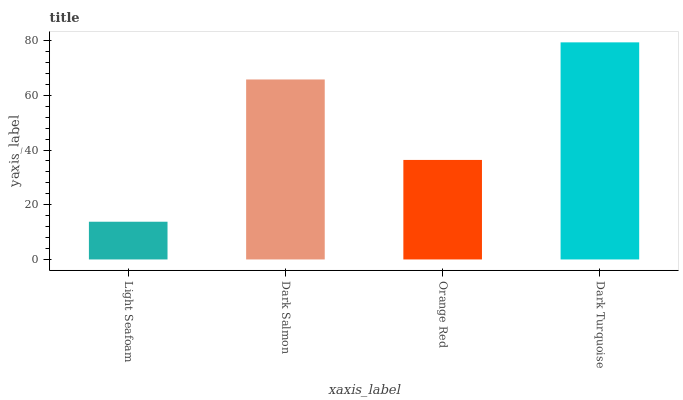Is Light Seafoam the minimum?
Answer yes or no. Yes. Is Dark Turquoise the maximum?
Answer yes or no. Yes. Is Dark Salmon the minimum?
Answer yes or no. No. Is Dark Salmon the maximum?
Answer yes or no. No. Is Dark Salmon greater than Light Seafoam?
Answer yes or no. Yes. Is Light Seafoam less than Dark Salmon?
Answer yes or no. Yes. Is Light Seafoam greater than Dark Salmon?
Answer yes or no. No. Is Dark Salmon less than Light Seafoam?
Answer yes or no. No. Is Dark Salmon the high median?
Answer yes or no. Yes. Is Orange Red the low median?
Answer yes or no. Yes. Is Orange Red the high median?
Answer yes or no. No. Is Dark Turquoise the low median?
Answer yes or no. No. 